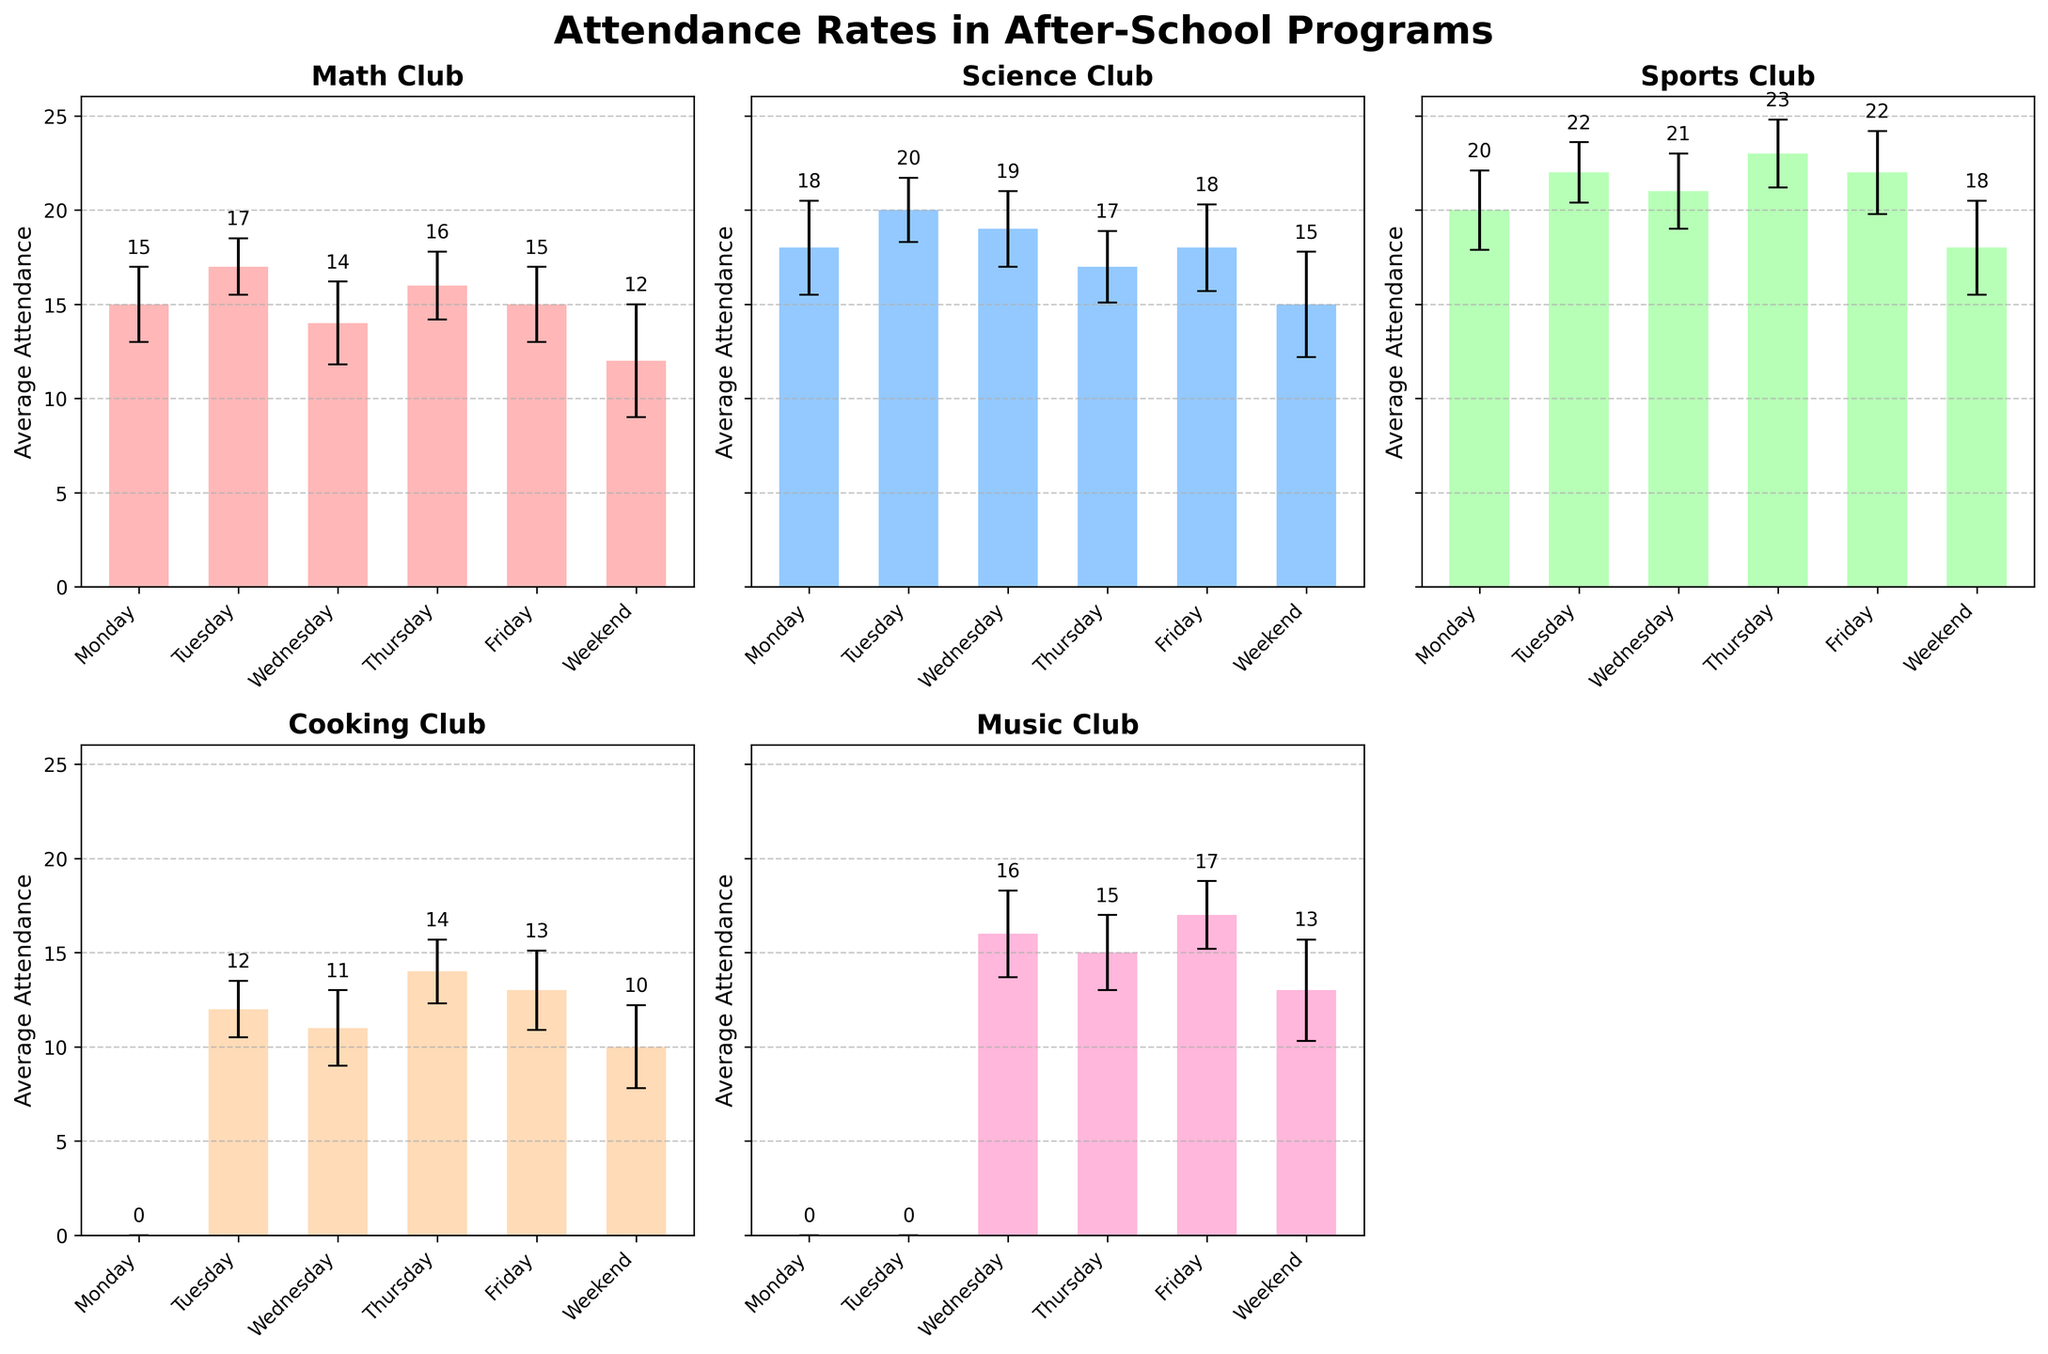What is the title of the plot? The title of the plot is written at the top of the figure in bold font.
Answer: Attendance Rates in After-School Programs Which club has the highest attendance on Tuesday? Look at the attendance bars for Tuesday in each subplot. The highest bar is for the program with the highest attendance.
Answer: Sports Club On which weekday does Math Club have the lowest attendance? Check the bars for Math Club across all weekdays. The lowest attendance bar will indicate the weekday.
Answer: Wednesday How does the average attendance of Science Club compare between weekdays and weekends? Look at the height of the bars for Science Club over the weekdays and compare it with the weekend bar.
Answer: Weekdays have higher attendance What is the error margin for Cooking Club on Wednesday? Identify the error bar for Cooking Club on Wednesday, which is represented as a vertical line extending from the top of the bar.
Answer: 2 What is the total attendance for Math Club across all weekdays? Summing the attendance figures for Monday, Tuesday, Wednesday, Thursday, and Friday for Math Club. (15 + 17 + 14 + 16 + 15) = 77
Answer: 77 Which program has the largest error margin on weekends? Look at the length of the error bars for each program on weekends and identify the largest one.
Answer: Math Club Between Wednesday and Thursday, which day has higher average attendance in Cooking Club? Compare the heights of the bars for Cooking Club on Wednesday and Thursday.
Answer: Thursday How does Music Club's attendance on Friday compare to its attendance on weekends? Compare the height of the Music Club's bar on Friday to its bar on the weekend.
Answer: Higher on Friday Which after-school program shows the least variation in attendance during weekdays? Examine the length of the error bars for all programs during weekdays and identify the program with the shortest error bars.
Answer: Cooking Club 